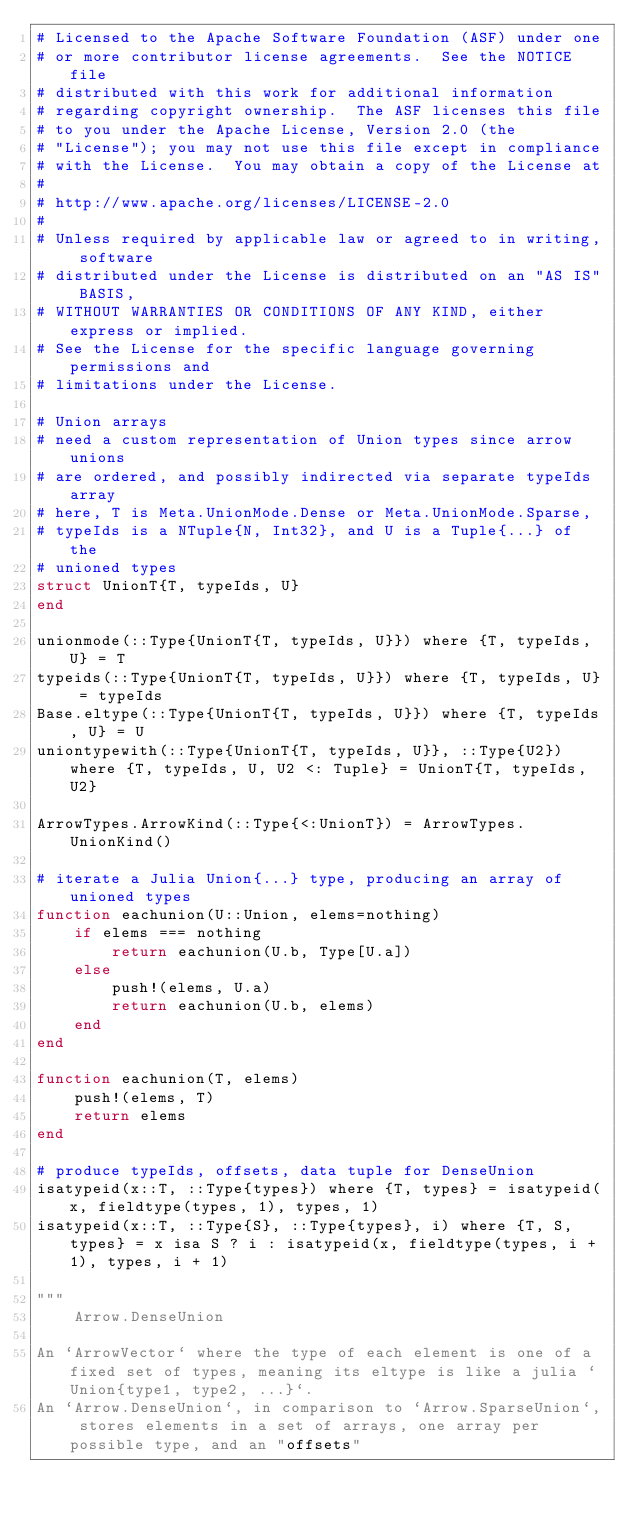<code> <loc_0><loc_0><loc_500><loc_500><_Julia_># Licensed to the Apache Software Foundation (ASF) under one
# or more contributor license agreements.  See the NOTICE file
# distributed with this work for additional information
# regarding copyright ownership.  The ASF licenses this file
# to you under the Apache License, Version 2.0 (the
# "License"); you may not use this file except in compliance
# with the License.  You may obtain a copy of the License at
#
# http://www.apache.org/licenses/LICENSE-2.0
#
# Unless required by applicable law or agreed to in writing, software
# distributed under the License is distributed on an "AS IS" BASIS,
# WITHOUT WARRANTIES OR CONDITIONS OF ANY KIND, either express or implied.
# See the License for the specific language governing permissions and
# limitations under the License.

# Union arrays
# need a custom representation of Union types since arrow unions
# are ordered, and possibly indirected via separate typeIds array
# here, T is Meta.UnionMode.Dense or Meta.UnionMode.Sparse,
# typeIds is a NTuple{N, Int32}, and U is a Tuple{...} of the
# unioned types
struct UnionT{T, typeIds, U}
end

unionmode(::Type{UnionT{T, typeIds, U}}) where {T, typeIds, U} = T
typeids(::Type{UnionT{T, typeIds, U}}) where {T, typeIds, U} = typeIds
Base.eltype(::Type{UnionT{T, typeIds, U}}) where {T, typeIds, U} = U
uniontypewith(::Type{UnionT{T, typeIds, U}}, ::Type{U2}) where {T, typeIds, U, U2 <: Tuple} = UnionT{T, typeIds, U2}

ArrowTypes.ArrowKind(::Type{<:UnionT}) = ArrowTypes.UnionKind()

# iterate a Julia Union{...} type, producing an array of unioned types
function eachunion(U::Union, elems=nothing)
    if elems === nothing
        return eachunion(U.b, Type[U.a])
    else
        push!(elems, U.a)
        return eachunion(U.b, elems)
    end
end

function eachunion(T, elems)
    push!(elems, T)
    return elems
end

# produce typeIds, offsets, data tuple for DenseUnion
isatypeid(x::T, ::Type{types}) where {T, types} = isatypeid(x, fieldtype(types, 1), types, 1)
isatypeid(x::T, ::Type{S}, ::Type{types}, i) where {T, S, types} = x isa S ? i : isatypeid(x, fieldtype(types, i + 1), types, i + 1)

"""
    Arrow.DenseUnion

An `ArrowVector` where the type of each element is one of a fixed set of types, meaning its eltype is like a julia `Union{type1, type2, ...}`.
An `Arrow.DenseUnion`, in comparison to `Arrow.SparseUnion`, stores elements in a set of arrays, one array per possible type, and an "offsets"</code> 